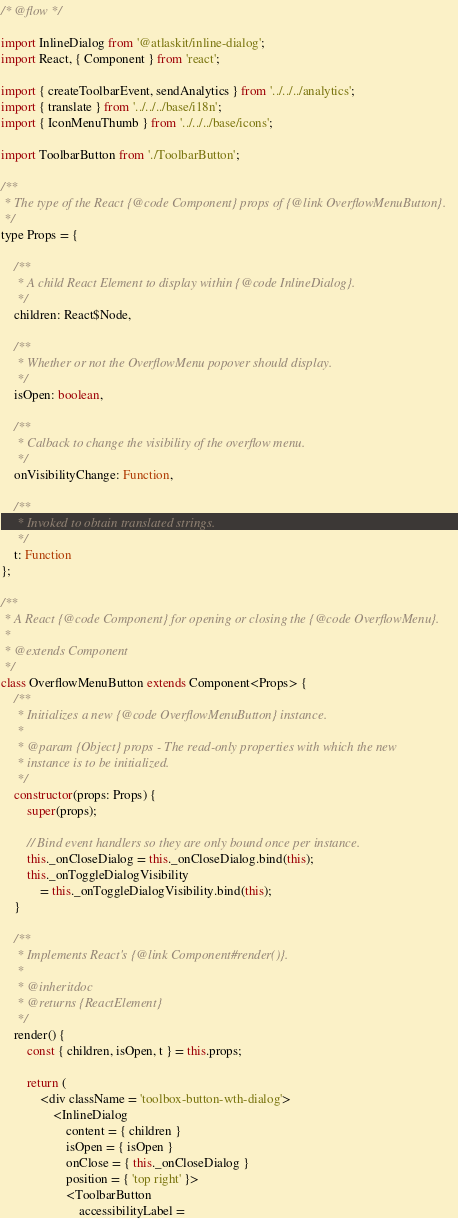Convert code to text. <code><loc_0><loc_0><loc_500><loc_500><_JavaScript_>/* @flow */

import InlineDialog from '@atlaskit/inline-dialog';
import React, { Component } from 'react';

import { createToolbarEvent, sendAnalytics } from '../../../analytics';
import { translate } from '../../../base/i18n';
import { IconMenuThumb } from '../../../base/icons';

import ToolbarButton from './ToolbarButton';

/**
 * The type of the React {@code Component} props of {@link OverflowMenuButton}.
 */
type Props = {

    /**
     * A child React Element to display within {@code InlineDialog}.
     */
    children: React$Node,

    /**
     * Whether or not the OverflowMenu popover should display.
     */
    isOpen: boolean,

    /**
     * Calback to change the visibility of the overflow menu.
     */
    onVisibilityChange: Function,

    /**
     * Invoked to obtain translated strings.
     */
    t: Function
};

/**
 * A React {@code Component} for opening or closing the {@code OverflowMenu}.
 *
 * @extends Component
 */
class OverflowMenuButton extends Component<Props> {
    /**
     * Initializes a new {@code OverflowMenuButton} instance.
     *
     * @param {Object} props - The read-only properties with which the new
     * instance is to be initialized.
     */
    constructor(props: Props) {
        super(props);

        // Bind event handlers so they are only bound once per instance.
        this._onCloseDialog = this._onCloseDialog.bind(this);
        this._onToggleDialogVisibility
            = this._onToggleDialogVisibility.bind(this);
    }

    /**
     * Implements React's {@link Component#render()}.
     *
     * @inheritdoc
     * @returns {ReactElement}
     */
    render() {
        const { children, isOpen, t } = this.props;

        return (
            <div className = 'toolbox-button-wth-dialog'>
                <InlineDialog
                    content = { children }
                    isOpen = { isOpen }
                    onClose = { this._onCloseDialog }
                    position = { 'top right' }>
                    <ToolbarButton
                        accessibilityLabel =</code> 